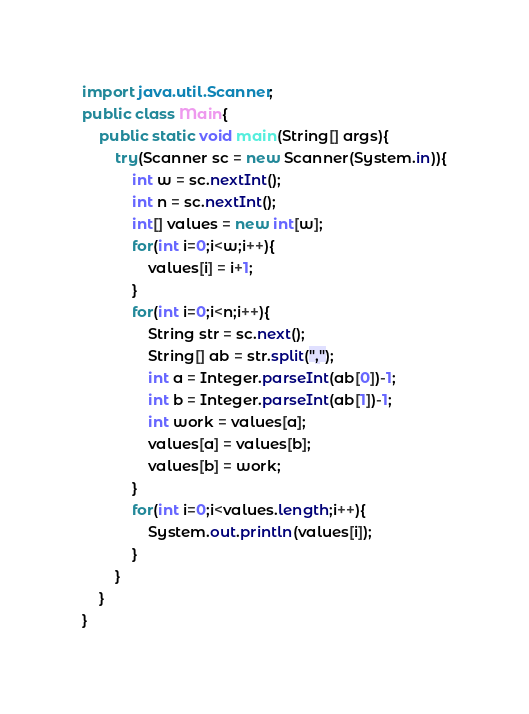Convert code to text. <code><loc_0><loc_0><loc_500><loc_500><_Java_>import java.util.Scanner;
public class Main{
    public static void main(String[] args){
        try(Scanner sc = new Scanner(System.in)){
            int w = sc.nextInt();
            int n = sc.nextInt();
            int[] values = new int[w];
            for(int i=0;i<w;i++){
                values[i] = i+1;
            }
            for(int i=0;i<n;i++){
                String str = sc.next();
                String[] ab = str.split(",");
                int a = Integer.parseInt(ab[0])-1;
                int b = Integer.parseInt(ab[1])-1;
                int work = values[a];
                values[a] = values[b];
                values[b] = work;
            }
            for(int i=0;i<values.length;i++){
                System.out.println(values[i]);
            }
        }
    }
}
</code> 